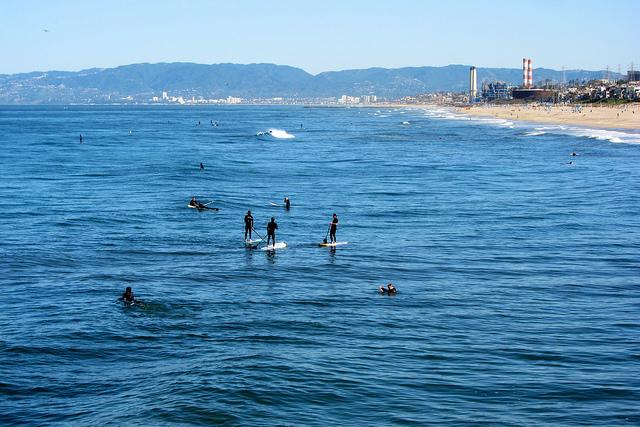Are there mountains in the distance?
Concise answer only. Yes. How many people are in the photo?
Keep it brief. 14. Are there waves on the water?
Answer briefly. Yes. How many surfers have the same colored swimsuits on?
Concise answer only. 3. What type of bird is flying over water?
Concise answer only. Seagull. What is in the water?
Write a very short answer. People. What is the person doing?
Write a very short answer. Surfing. What sport are the people doing?
Write a very short answer. Surfing. How many people are in the background?
Answer briefly. Many. 